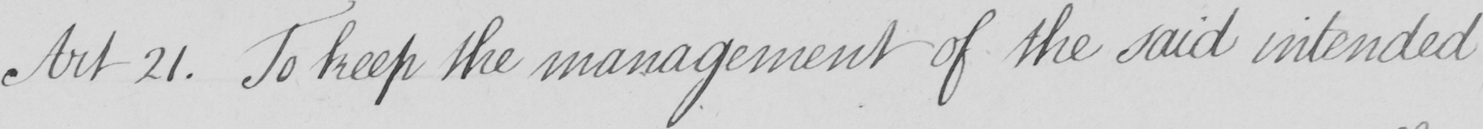Can you tell me what this handwritten text says? Art 21 . To keep the management of the said intended 